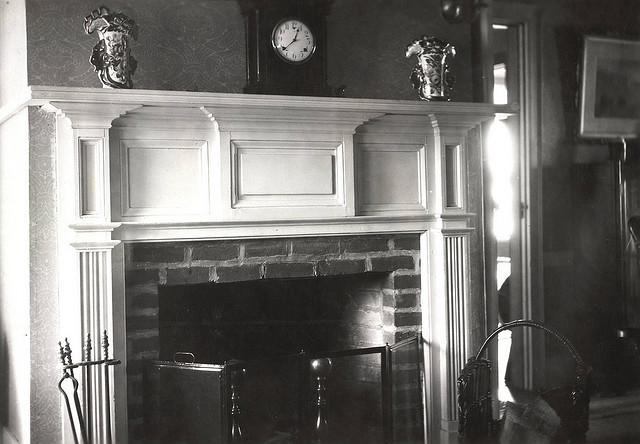What is under the mantle?
Concise answer only. Fireplace. What time does the clock show?
Write a very short answer. 12:40. How many items are on the mantle?
Keep it brief. 3. 